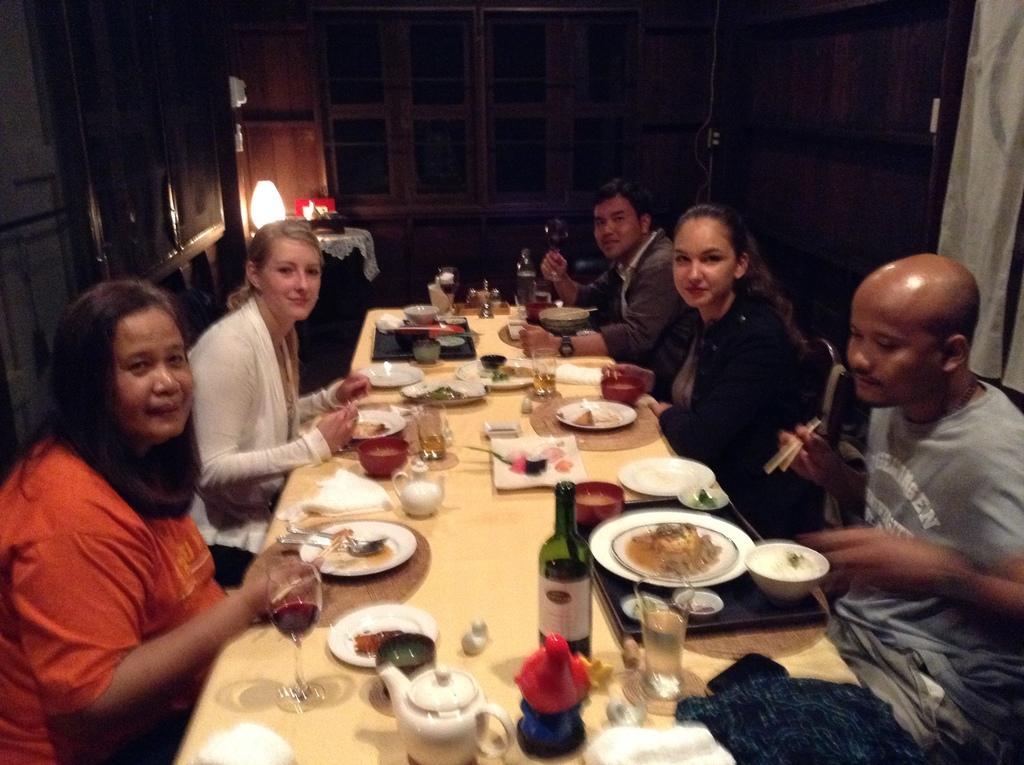Please provide a concise description of this image. A group of five people are having their dinner at a dining table. 